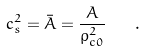<formula> <loc_0><loc_0><loc_500><loc_500>c _ { s } ^ { 2 } = \bar { A } = \frac { A } { \rho _ { c 0 } ^ { 2 } } \quad .</formula> 